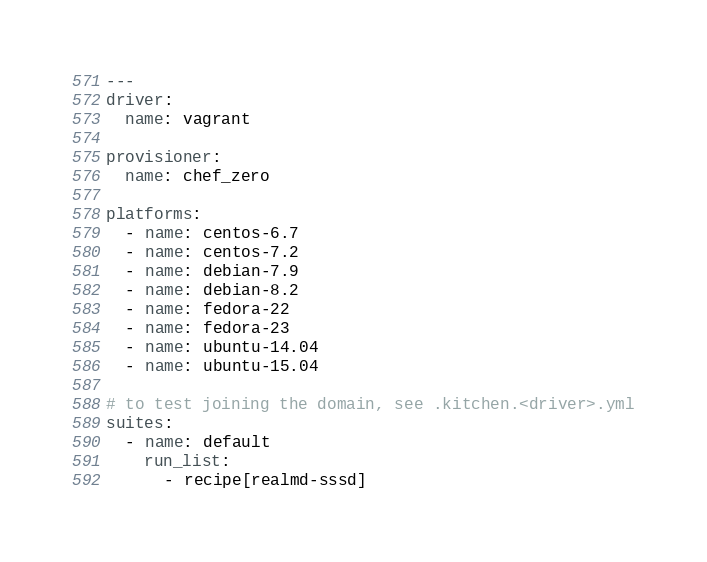Convert code to text. <code><loc_0><loc_0><loc_500><loc_500><_YAML_>---
driver:
  name: vagrant

provisioner:
  name: chef_zero

platforms:
  - name: centos-6.7
  - name: centos-7.2
  - name: debian-7.9
  - name: debian-8.2
  - name: fedora-22
  - name: fedora-23
  - name: ubuntu-14.04
  - name: ubuntu-15.04

# to test joining the domain, see .kitchen.<driver>.yml
suites:
  - name: default
    run_list:
      - recipe[realmd-sssd]
</code> 